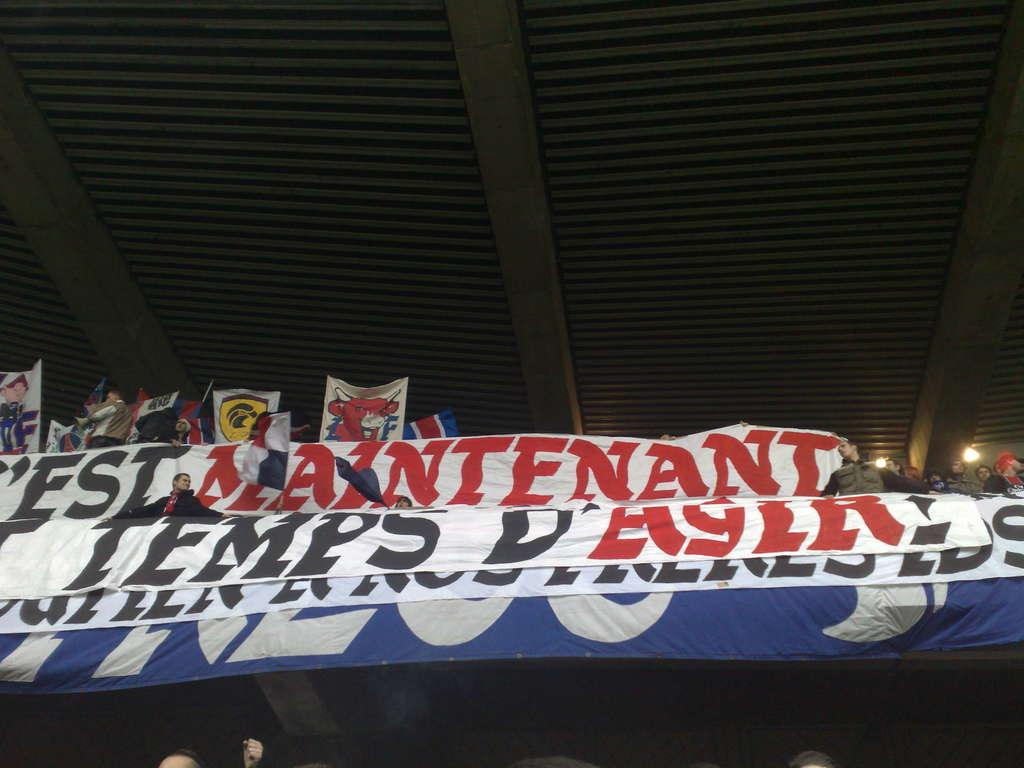What type of decorations can be seen in the image? There are banners and flags in the image. Are there any people present in the image? Yes, there are people in the image. What structure can be seen in the background of the image? There is a shed in the image. What is written on the banners? Something is written on the banners, but we cannot determine the exact message from the image. Can you see a burst of flame coming from the shed in the image? No, there is no burst of flame visible in the image. 